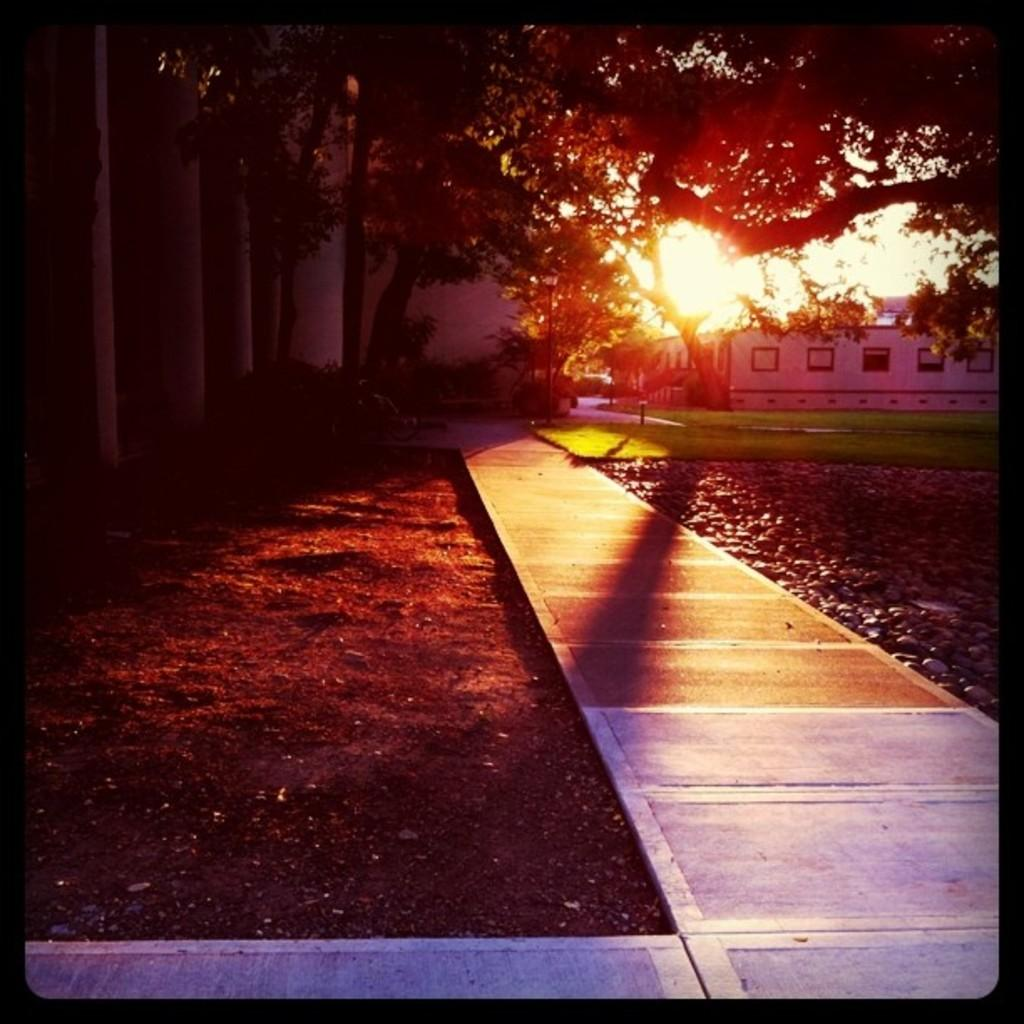What can be seen in the middle of the image? There are trees and buildings in the middle of the image. What is visible in the background of the image? The sky is visible in the background of the image. What type of objects are on the right side of the image? There are stones on the right side of the image. What type of soup is being served in the image? There is no soup present in the image. What season is depicted in the image? The provided facts do not mention any seasonal details, so it cannot be determined from the image. 